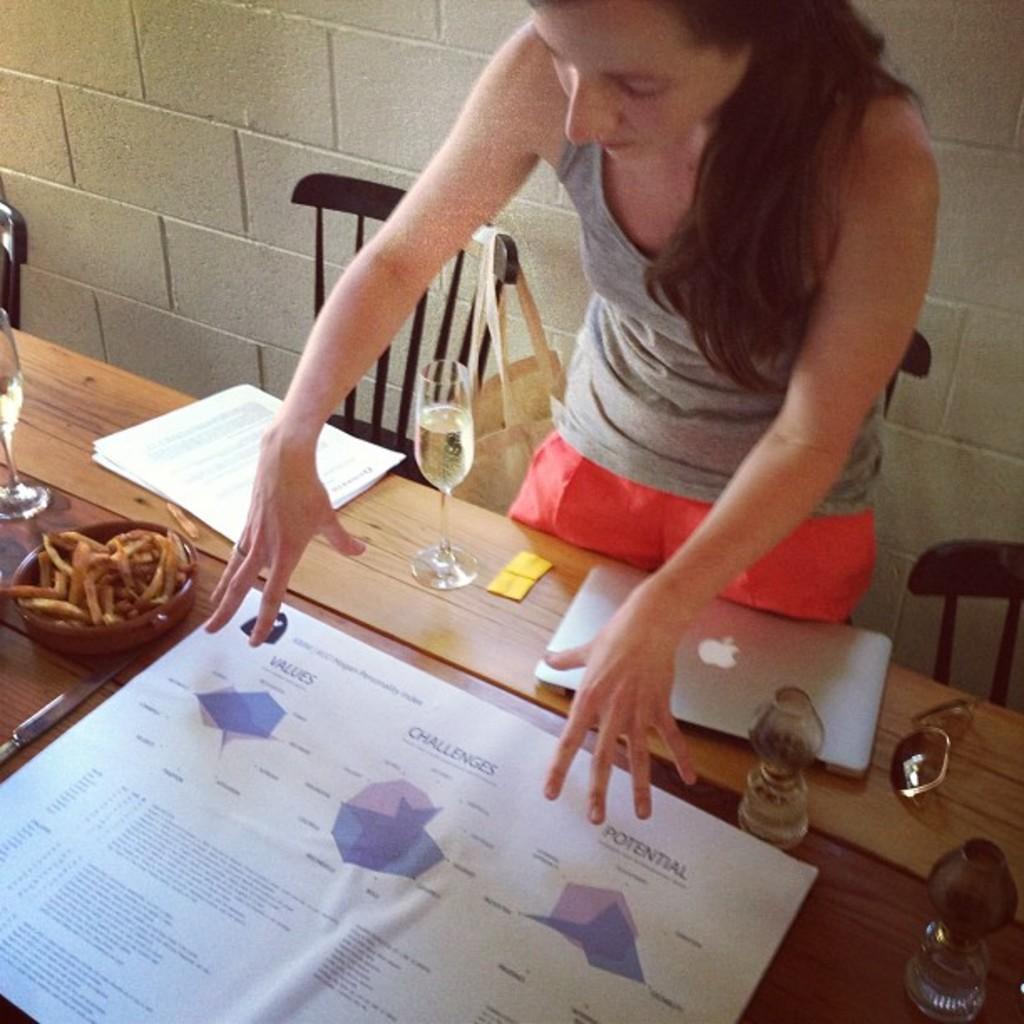Please provide a concise description of this image. In this picture there is a woman standing, she is looking at the poster kept on the table and there are some papers, laptop, a wine glass and some food in the bowl. 